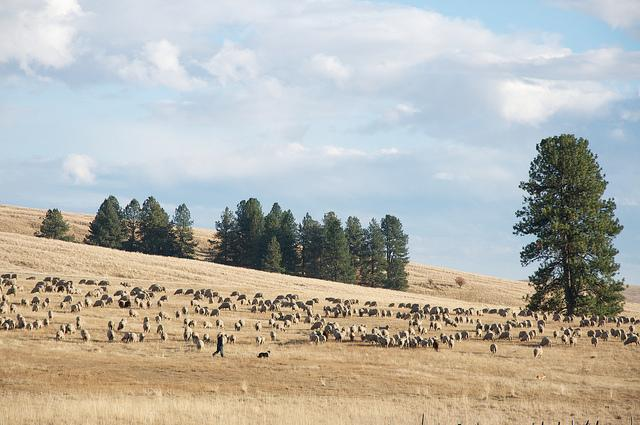What is the most probable reason there is a dog here? corral sheep 